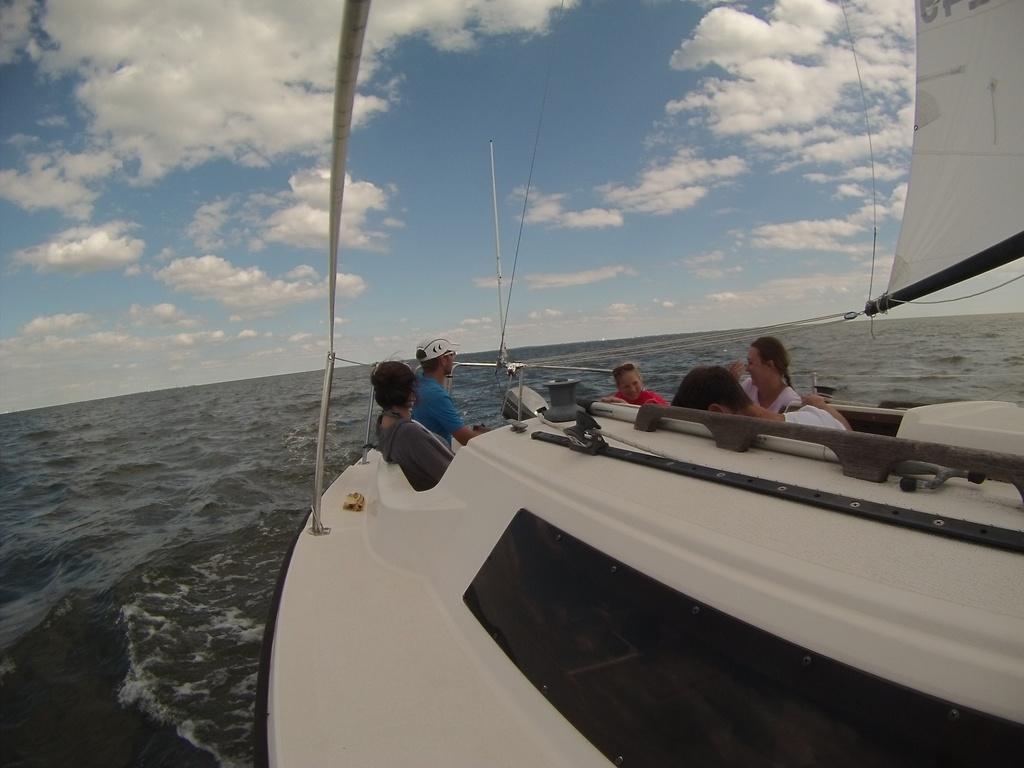In one or two sentences, can you explain what this image depicts? In this picture I can see few people sitting in the boat and I can see water and a blue cloudy sky. 